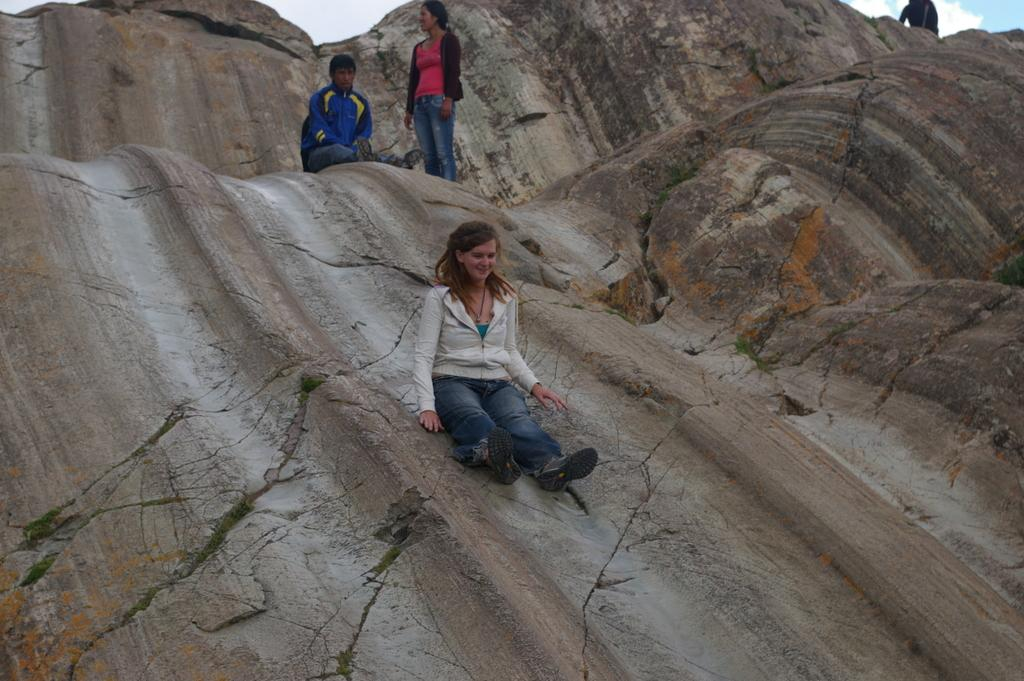How many people are present in the image? There are two persons sitting in the image. What is the third person in the image doing? There is a person standing on a rock in the image. What can be seen in the background of the image? The sky is visible in the background of the image. What type of game is being played by the people in the image? There is no indication of a game being played in the image; the people are simply sitting or standing. Are any masks visible in the image? No masks are visible in the image. 